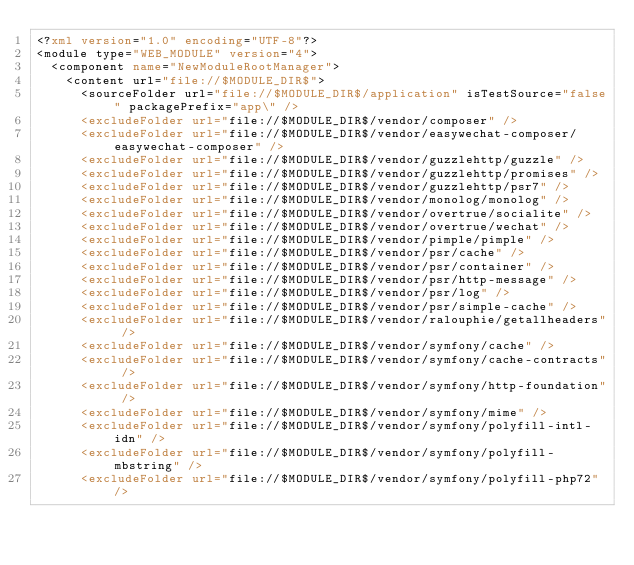<code> <loc_0><loc_0><loc_500><loc_500><_XML_><?xml version="1.0" encoding="UTF-8"?>
<module type="WEB_MODULE" version="4">
  <component name="NewModuleRootManager">
    <content url="file://$MODULE_DIR$">
      <sourceFolder url="file://$MODULE_DIR$/application" isTestSource="false" packagePrefix="app\" />
      <excludeFolder url="file://$MODULE_DIR$/vendor/composer" />
      <excludeFolder url="file://$MODULE_DIR$/vendor/easywechat-composer/easywechat-composer" />
      <excludeFolder url="file://$MODULE_DIR$/vendor/guzzlehttp/guzzle" />
      <excludeFolder url="file://$MODULE_DIR$/vendor/guzzlehttp/promises" />
      <excludeFolder url="file://$MODULE_DIR$/vendor/guzzlehttp/psr7" />
      <excludeFolder url="file://$MODULE_DIR$/vendor/monolog/monolog" />
      <excludeFolder url="file://$MODULE_DIR$/vendor/overtrue/socialite" />
      <excludeFolder url="file://$MODULE_DIR$/vendor/overtrue/wechat" />
      <excludeFolder url="file://$MODULE_DIR$/vendor/pimple/pimple" />
      <excludeFolder url="file://$MODULE_DIR$/vendor/psr/cache" />
      <excludeFolder url="file://$MODULE_DIR$/vendor/psr/container" />
      <excludeFolder url="file://$MODULE_DIR$/vendor/psr/http-message" />
      <excludeFolder url="file://$MODULE_DIR$/vendor/psr/log" />
      <excludeFolder url="file://$MODULE_DIR$/vendor/psr/simple-cache" />
      <excludeFolder url="file://$MODULE_DIR$/vendor/ralouphie/getallheaders" />
      <excludeFolder url="file://$MODULE_DIR$/vendor/symfony/cache" />
      <excludeFolder url="file://$MODULE_DIR$/vendor/symfony/cache-contracts" />
      <excludeFolder url="file://$MODULE_DIR$/vendor/symfony/http-foundation" />
      <excludeFolder url="file://$MODULE_DIR$/vendor/symfony/mime" />
      <excludeFolder url="file://$MODULE_DIR$/vendor/symfony/polyfill-intl-idn" />
      <excludeFolder url="file://$MODULE_DIR$/vendor/symfony/polyfill-mbstring" />
      <excludeFolder url="file://$MODULE_DIR$/vendor/symfony/polyfill-php72" /></code> 